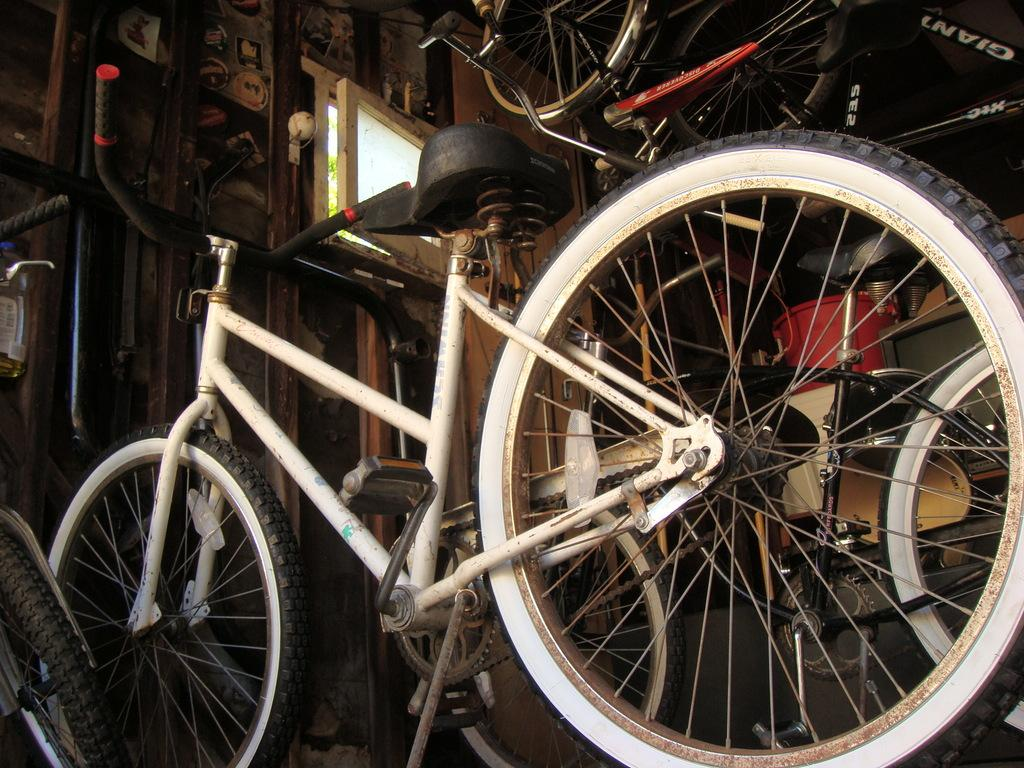What type of vehicles are in the image? There are cycles in the image. What can be seen in the background of the image? The background of the image is dark. What is the color of the red color thing in the image? There is a red color thing in the image, but the specific color cannot be determined without more information. What else is present in the image besides cycles and the red color thing? There is a window and equipment in the image. Can you see any ducks on the stage in the image? There is no stage or ducks present in the image. What type of basket is used to carry the equipment in the image? There is no basket visible in the image; the equipment is not being carried. 